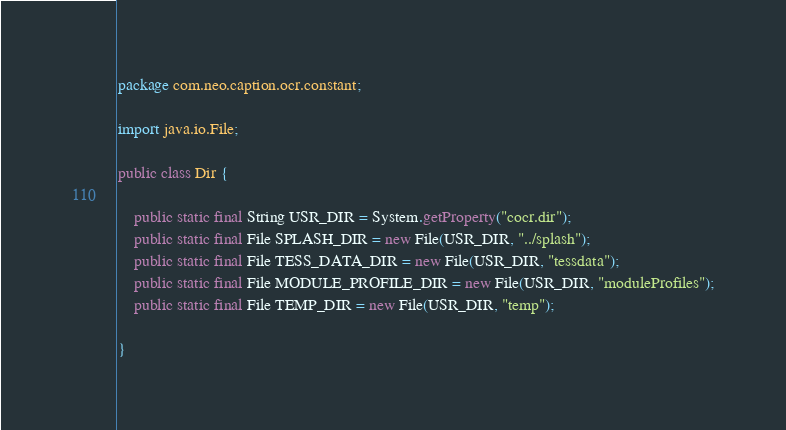Convert code to text. <code><loc_0><loc_0><loc_500><loc_500><_Java_>package com.neo.caption.ocr.constant;

import java.io.File;

public class Dir {

    public static final String USR_DIR = System.getProperty("cocr.dir");
    public static final File SPLASH_DIR = new File(USR_DIR, "../splash");
    public static final File TESS_DATA_DIR = new File(USR_DIR, "tessdata");
    public static final File MODULE_PROFILE_DIR = new File(USR_DIR, "moduleProfiles");
    public static final File TEMP_DIR = new File(USR_DIR, "temp");

}
</code> 